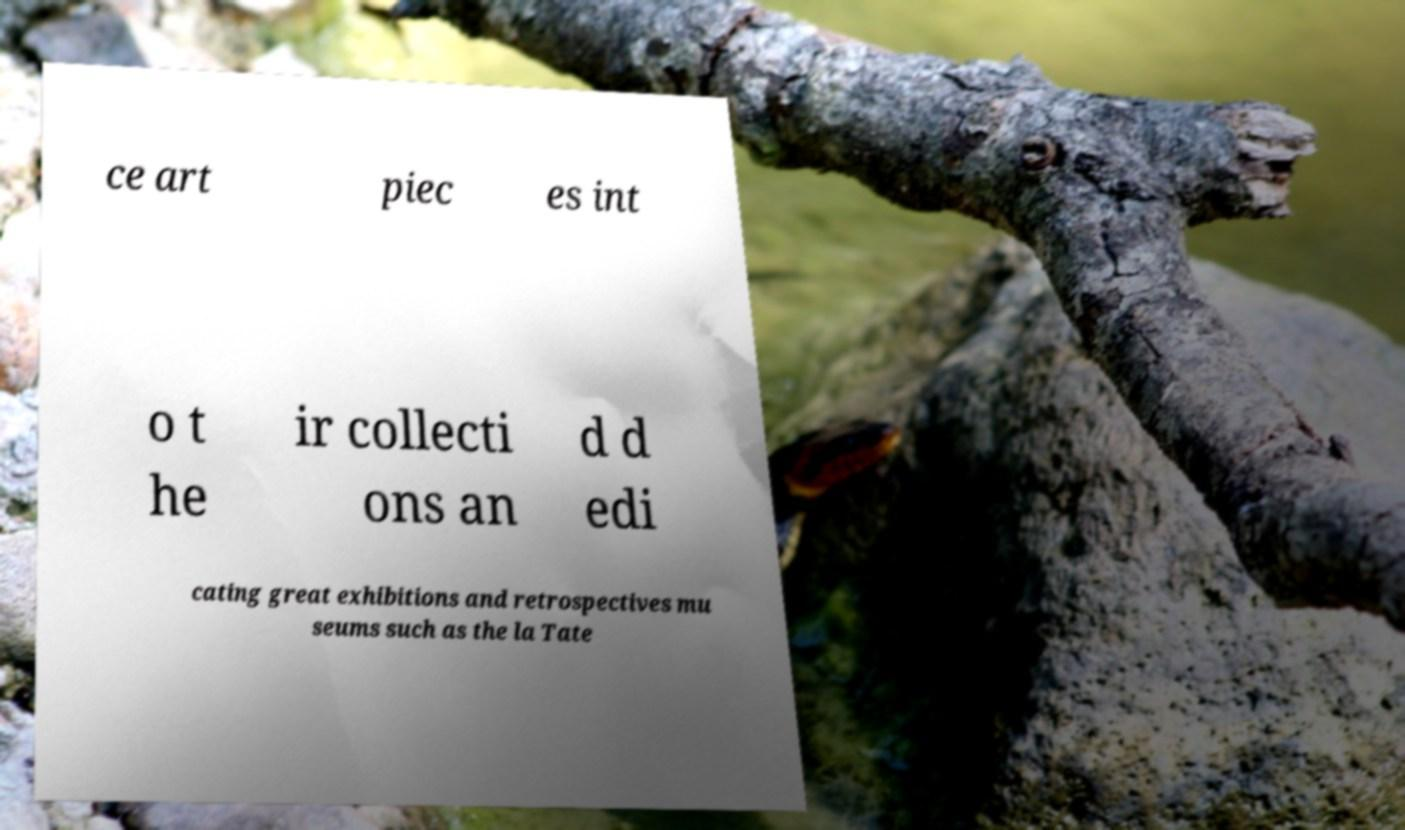I need the written content from this picture converted into text. Can you do that? ce art piec es int o t he ir collecti ons an d d edi cating great exhibitions and retrospectives mu seums such as the la Tate 